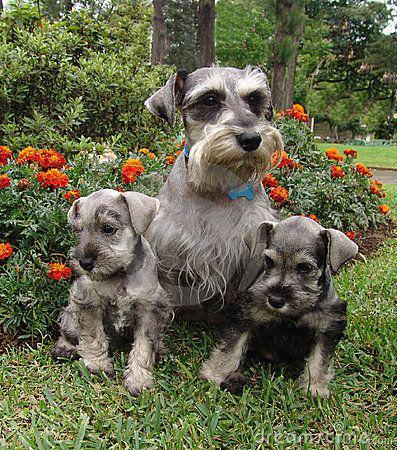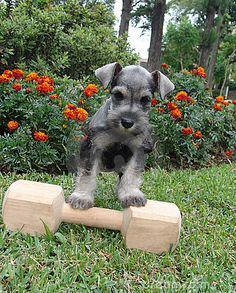The first image is the image on the left, the second image is the image on the right. Evaluate the accuracy of this statement regarding the images: "There are no more than four dogs". Is it true? Answer yes or no. Yes. 